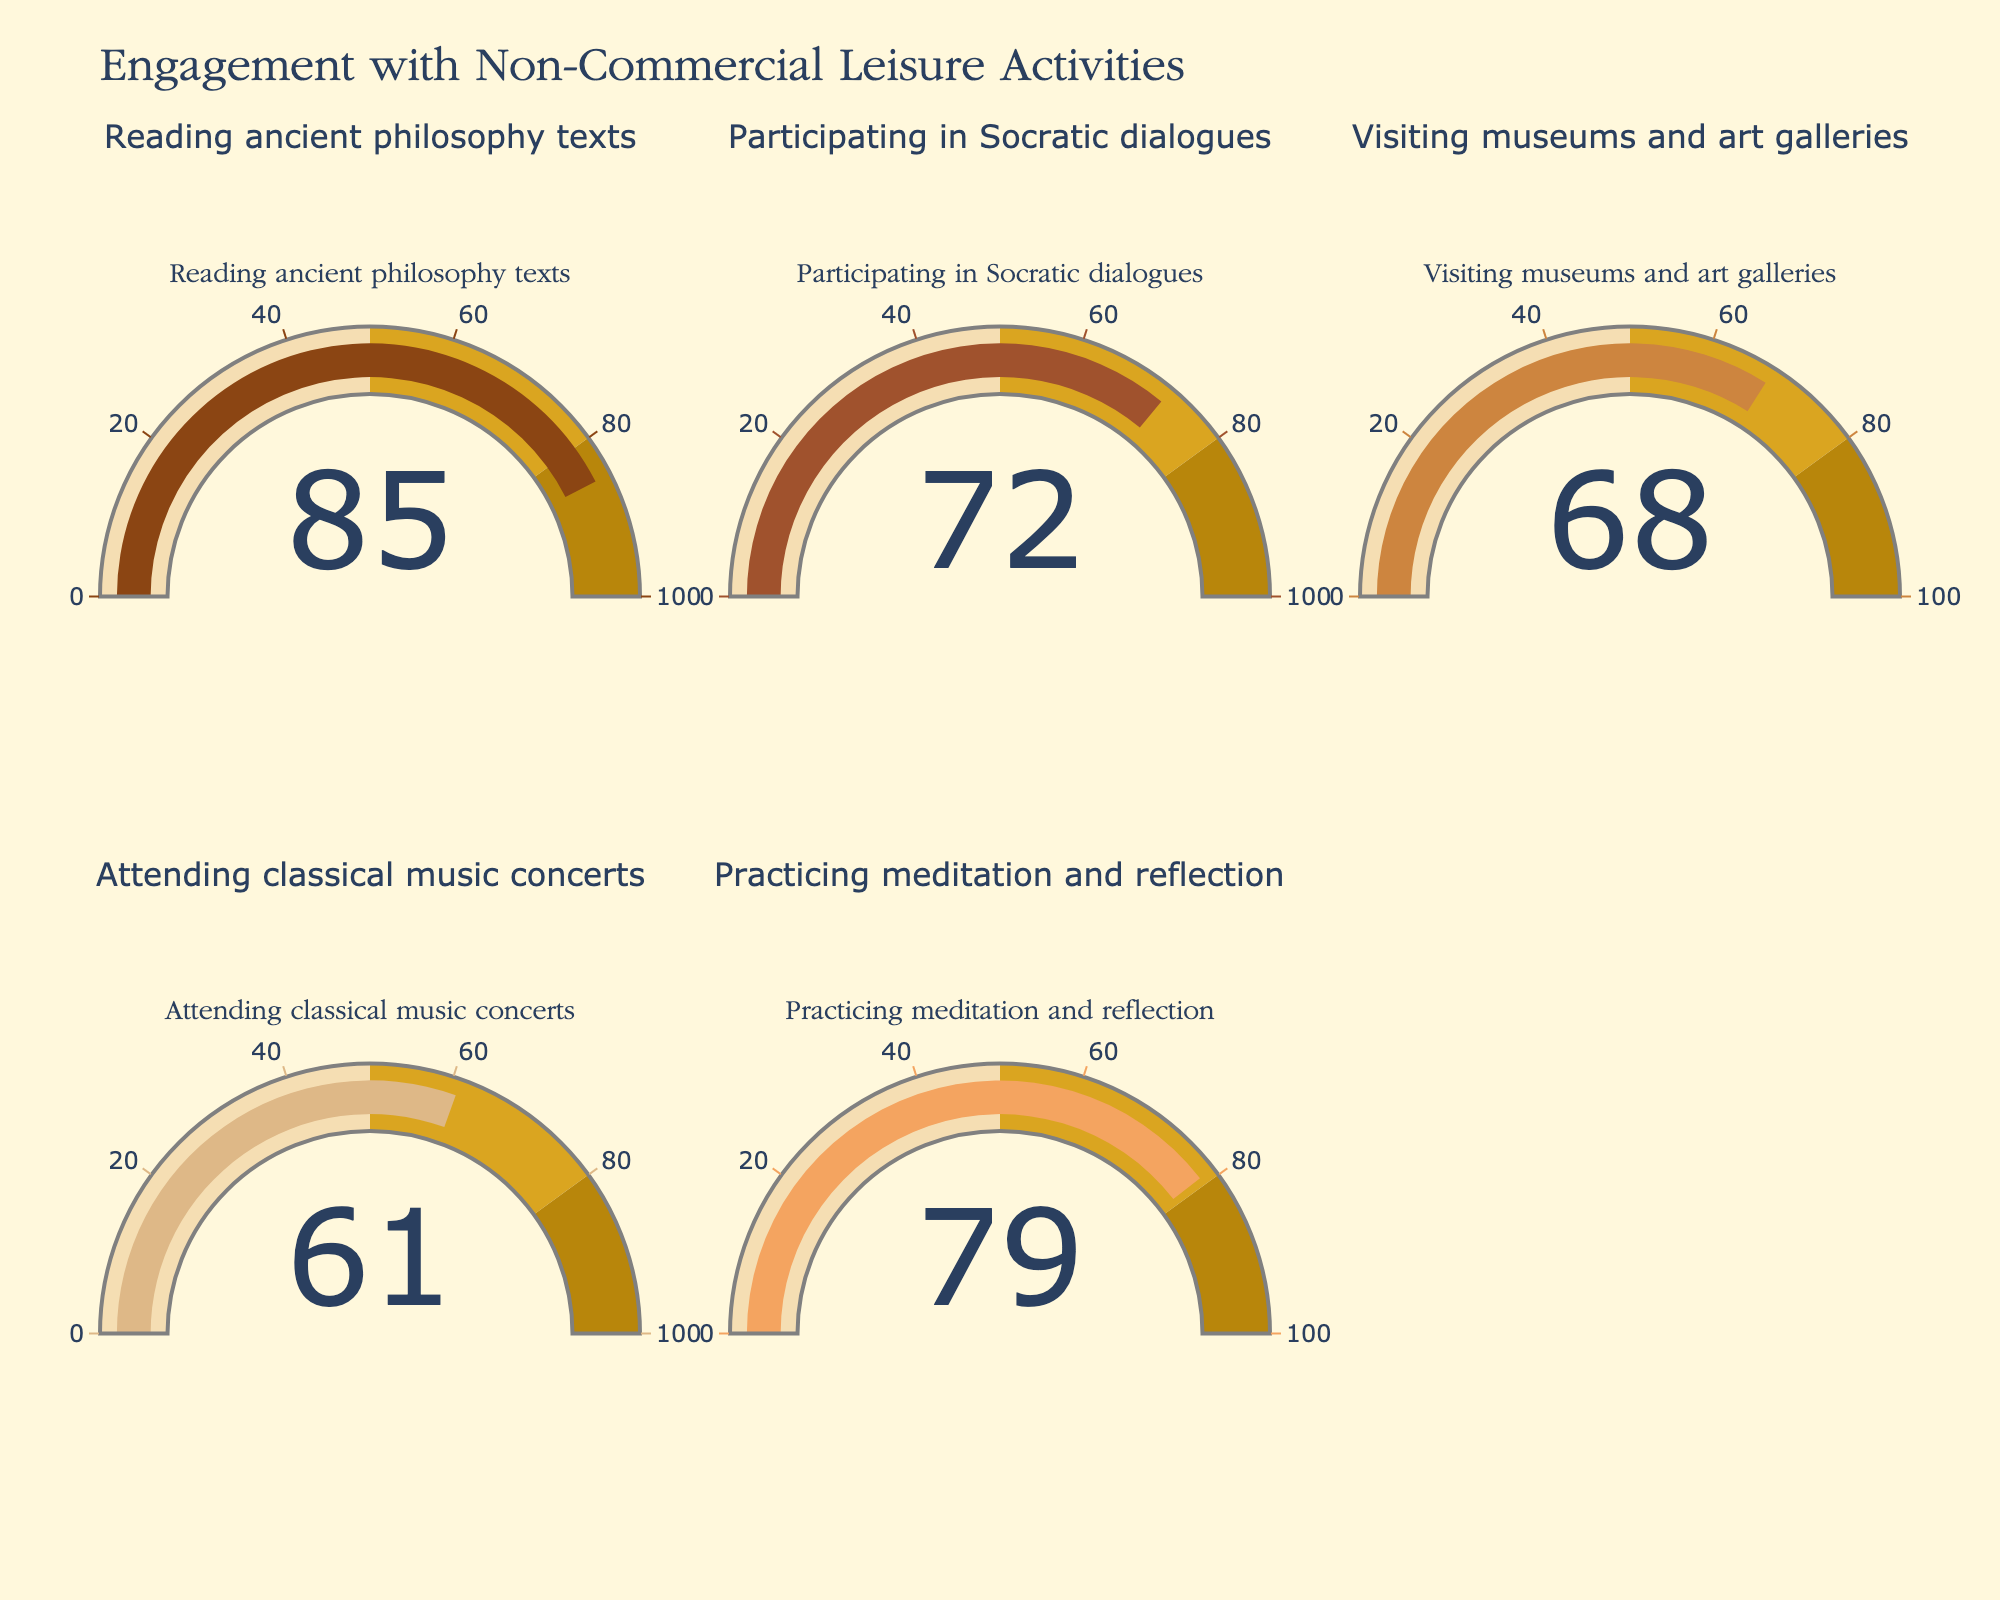Which activity has the highest engagement level? To find the activity with the highest engagement level, look at the values displayed on each gauge chart and identify the highest number among them. The activity "Reading ancient philosophy texts" shows the highest value of 85.
Answer: Reading ancient philosophy texts Which activity has the lowest engagement level? To determine the activity with the lowest engagement level, locate the smallest number displayed on the gauge charts. The activity "Attending classical music concerts" has the lowest value of 61.
Answer: Attending classical music concerts What is the average engagement level across all activities? To calculate the average engagement level, sum all the engagement levels and divide by the number of activities. Sum: 85 + 72 + 68 + 61 + 79 = 365. Number of activities: 5. Average: 365 / 5 = 73.
Answer: 73 How many activities have an engagement level above 70? Count the number of gauge charts where the displayed value is greater than 70. The activities "Reading ancient philosophy texts" (85), "Participating in Socratic dialogues" (72), and "Practicing meditation and reflection" (79) all have engagement levels above 70. There are 3 such activities.
Answer: 3 What is the median engagement level of the activities? To find the median, list the engagement levels in numerical order: 61, 68, 72, 79, 85. The median value, being the middle number in this ordered list, is 72.
Answer: 72 By how much does the highest engagement level exceed the lowest engagement level? Identify the highest and lowest engagement levels: 85 (highest for Reading ancient philosophy texts) and 61 (lowest for Attending classical music concerts). Subtract the lowest from the highest: 85 - 61 = 24.
Answer: 24 Which activities have an engagement level between 60 and 80 inclusive? Look for activities whose engagement levels fall in the range from 60 to 80. "Participating in Socratic dialogues" (72), "Visiting museums and art galleries" (68), "Attending classical music concerts" (61), and "Practicing meditation and reflection" (79) fall within this range.
Answer: Participating in Socratic dialogues, Visiting museums and art galleries, Attending classical music concerts, Practicing meditation and reflection How much lower is the engagement level of "Attending classical music concerts" compared to "Practicing meditation and reflection"? Identify the values for each activity: "Attending classical music concerts" (61) and "Practicing meditation and reflection" (79). Subtract the lower value from the higher value: 79 - 61 = 18.
Answer: 18 